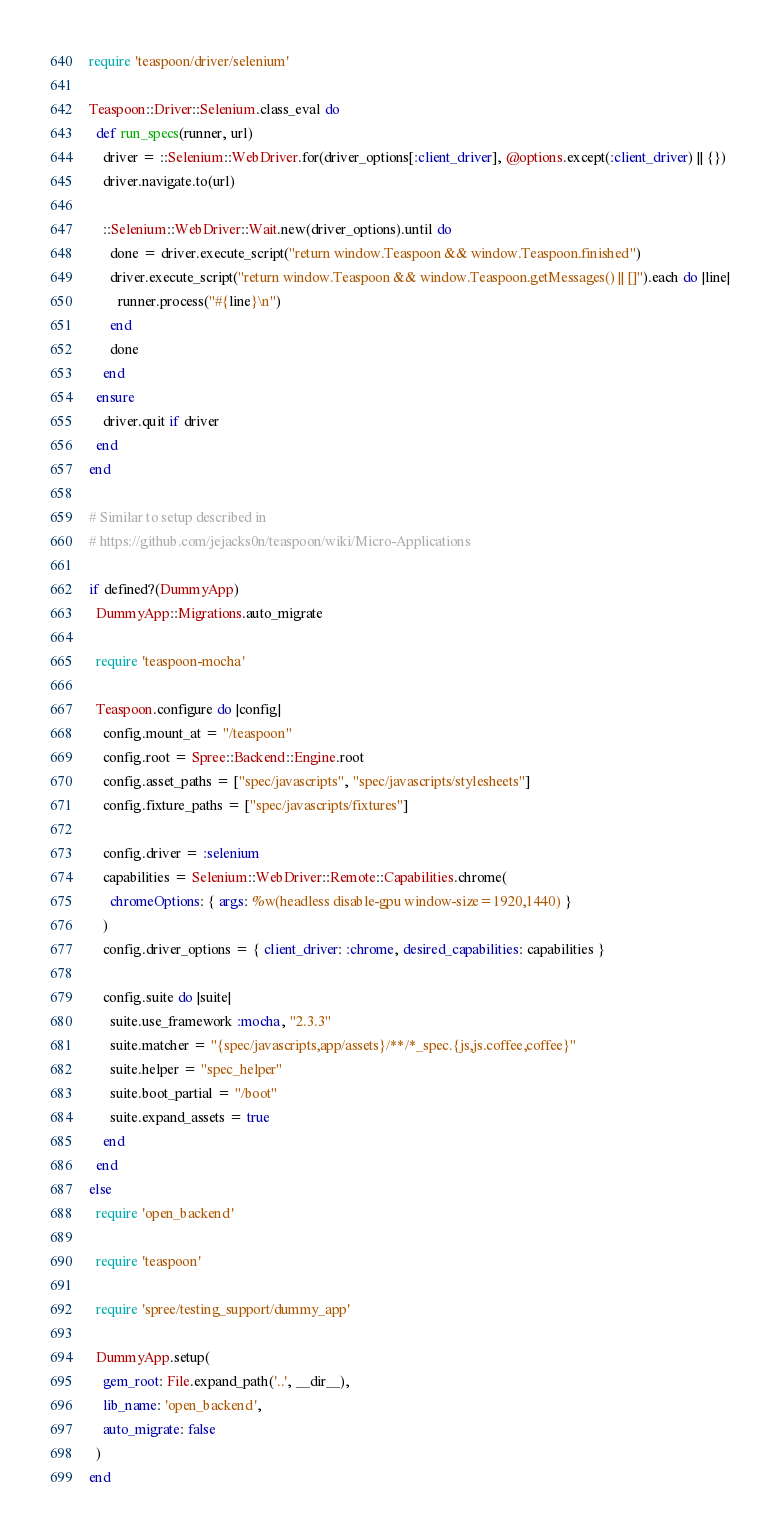<code> <loc_0><loc_0><loc_500><loc_500><_Ruby_>require 'teaspoon/driver/selenium'

Teaspoon::Driver::Selenium.class_eval do
  def run_specs(runner, url)
    driver = ::Selenium::WebDriver.for(driver_options[:client_driver], @options.except(:client_driver) || {})
    driver.navigate.to(url)

    ::Selenium::WebDriver::Wait.new(driver_options).until do
      done = driver.execute_script("return window.Teaspoon && window.Teaspoon.finished")
      driver.execute_script("return window.Teaspoon && window.Teaspoon.getMessages() || []").each do |line|
        runner.process("#{line}\n")
      end
      done
    end
  ensure
    driver.quit if driver
  end
end

# Similar to setup described in
# https://github.com/jejacks0n/teaspoon/wiki/Micro-Applications

if defined?(DummyApp)
  DummyApp::Migrations.auto_migrate

  require 'teaspoon-mocha'

  Teaspoon.configure do |config|
    config.mount_at = "/teaspoon"
    config.root = Spree::Backend::Engine.root
    config.asset_paths = ["spec/javascripts", "spec/javascripts/stylesheets"]
    config.fixture_paths = ["spec/javascripts/fixtures"]

    config.driver = :selenium
    capabilities = Selenium::WebDriver::Remote::Capabilities.chrome(
      chromeOptions: { args: %w(headless disable-gpu window-size=1920,1440) }
    )
    config.driver_options = { client_driver: :chrome, desired_capabilities: capabilities }

    config.suite do |suite|
      suite.use_framework :mocha, "2.3.3"
      suite.matcher = "{spec/javascripts,app/assets}/**/*_spec.{js,js.coffee,coffee}"
      suite.helper = "spec_helper"
      suite.boot_partial = "/boot"
      suite.expand_assets = true
    end
  end
else
  require 'open_backend'

  require 'teaspoon'

  require 'spree/testing_support/dummy_app'

  DummyApp.setup(
    gem_root: File.expand_path('..', __dir__),
    lib_name: 'open_backend',
    auto_migrate: false
  )
end
</code> 